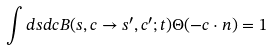Convert formula to latex. <formula><loc_0><loc_0><loc_500><loc_500>\int d { s } d { c } B ( { s } , { c } \rightarrow { s ^ { \prime } } , { c ^ { \prime } } ; t ) \Theta ( - { c } \cdot { n } ) = 1</formula> 